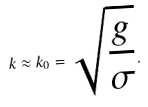Convert formula to latex. <formula><loc_0><loc_0><loc_500><loc_500>k \approx k _ { 0 } = \sqrt { \frac { g } { \sigma } } .</formula> 